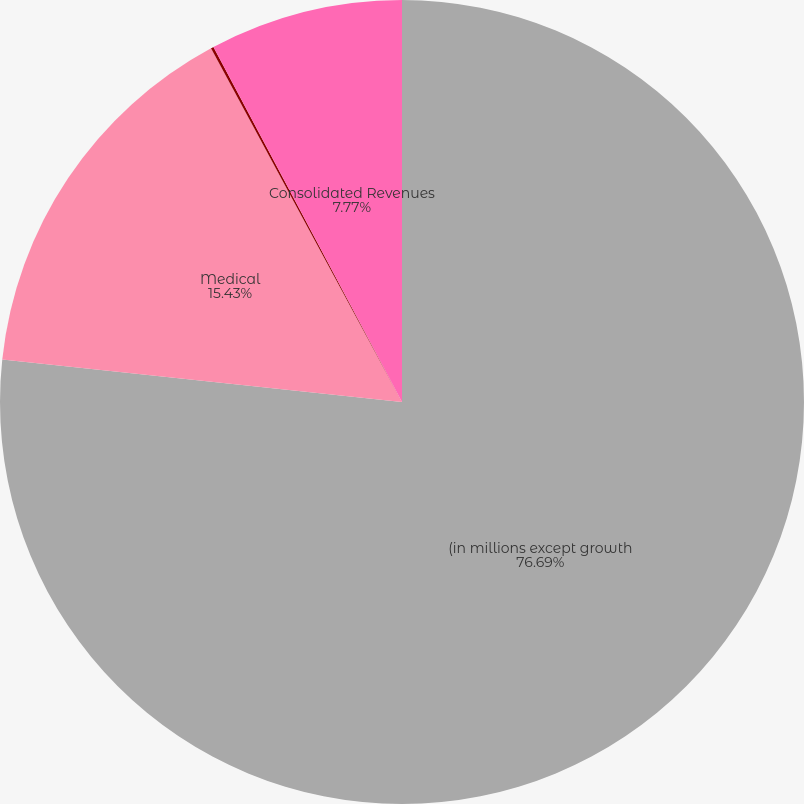Convert chart. <chart><loc_0><loc_0><loc_500><loc_500><pie_chart><fcel>(in millions except growth<fcel>Medical<fcel>Total Segment Revenue<fcel>Consolidated Revenues<nl><fcel>76.69%<fcel>15.43%<fcel>0.11%<fcel>7.77%<nl></chart> 